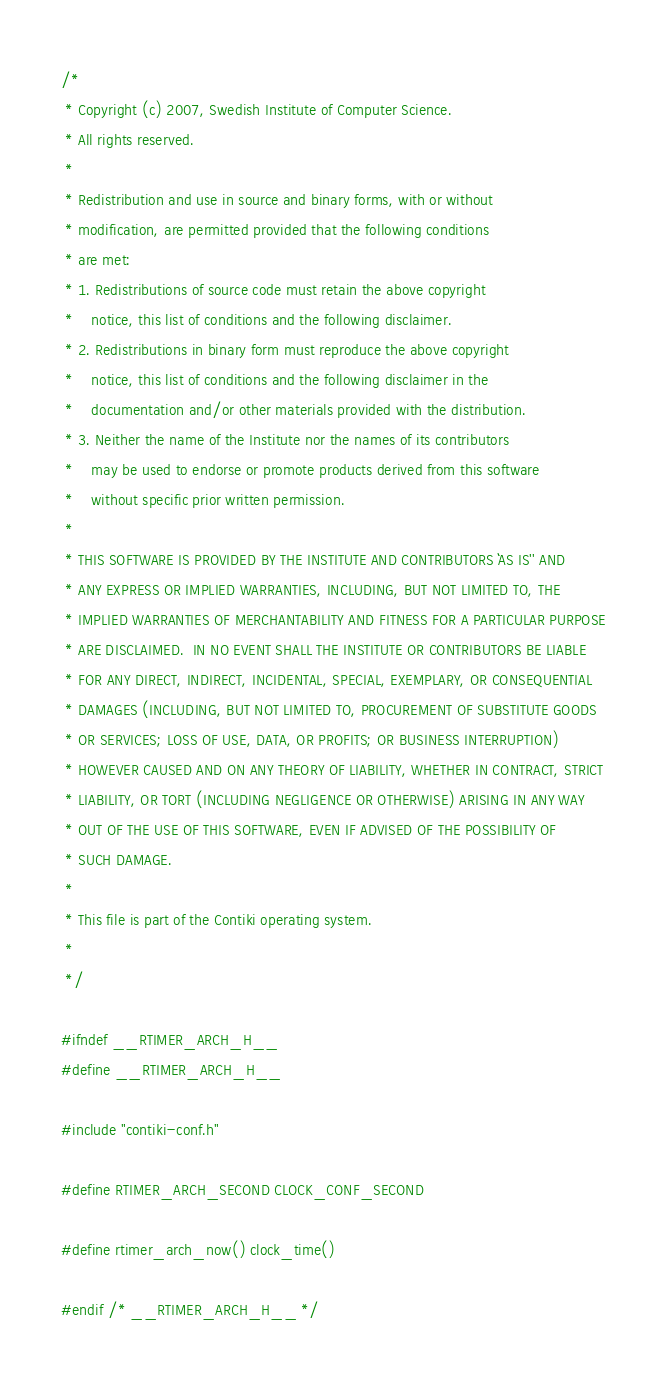Convert code to text. <code><loc_0><loc_0><loc_500><loc_500><_C_>/*
 * Copyright (c) 2007, Swedish Institute of Computer Science.
 * All rights reserved. 
 *
 * Redistribution and use in source and binary forms, with or without 
 * modification, are permitted provided that the following conditions 
 * are met: 
 * 1. Redistributions of source code must retain the above copyright 
 *    notice, this list of conditions and the following disclaimer. 
 * 2. Redistributions in binary form must reproduce the above copyright 
 *    notice, this list of conditions and the following disclaimer in the 
 *    documentation and/or other materials provided with the distribution. 
 * 3. Neither the name of the Institute nor the names of its contributors 
 *    may be used to endorse or promote products derived from this software 
 *    without specific prior written permission. 
 *
 * THIS SOFTWARE IS PROVIDED BY THE INSTITUTE AND CONTRIBUTORS ``AS IS'' AND 
 * ANY EXPRESS OR IMPLIED WARRANTIES, INCLUDING, BUT NOT LIMITED TO, THE 
 * IMPLIED WARRANTIES OF MERCHANTABILITY AND FITNESS FOR A PARTICULAR PURPOSE 
 * ARE DISCLAIMED.  IN NO EVENT SHALL THE INSTITUTE OR CONTRIBUTORS BE LIABLE 
 * FOR ANY DIRECT, INDIRECT, INCIDENTAL, SPECIAL, EXEMPLARY, OR CONSEQUENTIAL 
 * DAMAGES (INCLUDING, BUT NOT LIMITED TO, PROCUREMENT OF SUBSTITUTE GOODS 
 * OR SERVICES; LOSS OF USE, DATA, OR PROFITS; OR BUSINESS INTERRUPTION) 
 * HOWEVER CAUSED AND ON ANY THEORY OF LIABILITY, WHETHER IN CONTRACT, STRICT 
 * LIABILITY, OR TORT (INCLUDING NEGLIGENCE OR OTHERWISE) ARISING IN ANY WAY 
 * OUT OF THE USE OF THIS SOFTWARE, EVEN IF ADVISED OF THE POSSIBILITY OF 
 * SUCH DAMAGE. 
 *
 * This file is part of the Contiki operating system.
 * 
 */

#ifndef __RTIMER_ARCH_H__
#define __RTIMER_ARCH_H__

#include "contiki-conf.h"

#define RTIMER_ARCH_SECOND CLOCK_CONF_SECOND

#define rtimer_arch_now() clock_time()

#endif /* __RTIMER_ARCH_H__ */
</code> 